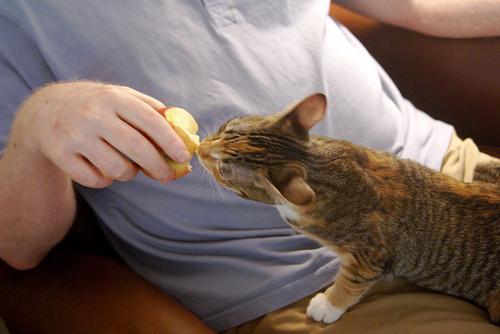How many cats are there?
Give a very brief answer. 1. 